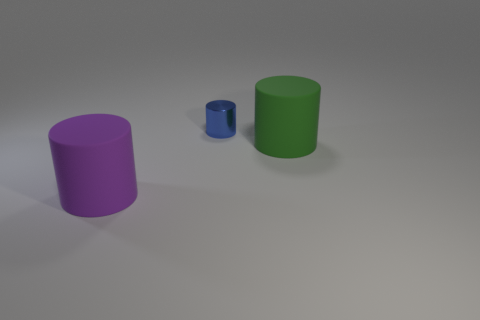Does the big green cylinder have the same material as the object that is left of the blue object?
Give a very brief answer. Yes. The thing that is in front of the big cylinder that is behind the purple object is what shape?
Your answer should be very brief. Cylinder. There is a thing that is both behind the purple cylinder and in front of the blue metal object; what shape is it?
Offer a very short reply. Cylinder. How many things are either matte cylinders or big objects that are behind the large purple rubber thing?
Provide a short and direct response. 2. There is a blue thing that is the same shape as the big purple object; what is it made of?
Offer a terse response. Metal. Is there anything else that has the same material as the small thing?
Ensure brevity in your answer.  No. What is the object that is behind the big purple matte object and in front of the tiny cylinder made of?
Give a very brief answer. Rubber. How many other small blue objects have the same shape as the small blue object?
Keep it short and to the point. 0. What color is the object behind the green object that is to the right of the tiny metal cylinder?
Your answer should be compact. Blue. Is the number of green cylinders right of the purple cylinder the same as the number of large green matte cylinders?
Keep it short and to the point. Yes. 